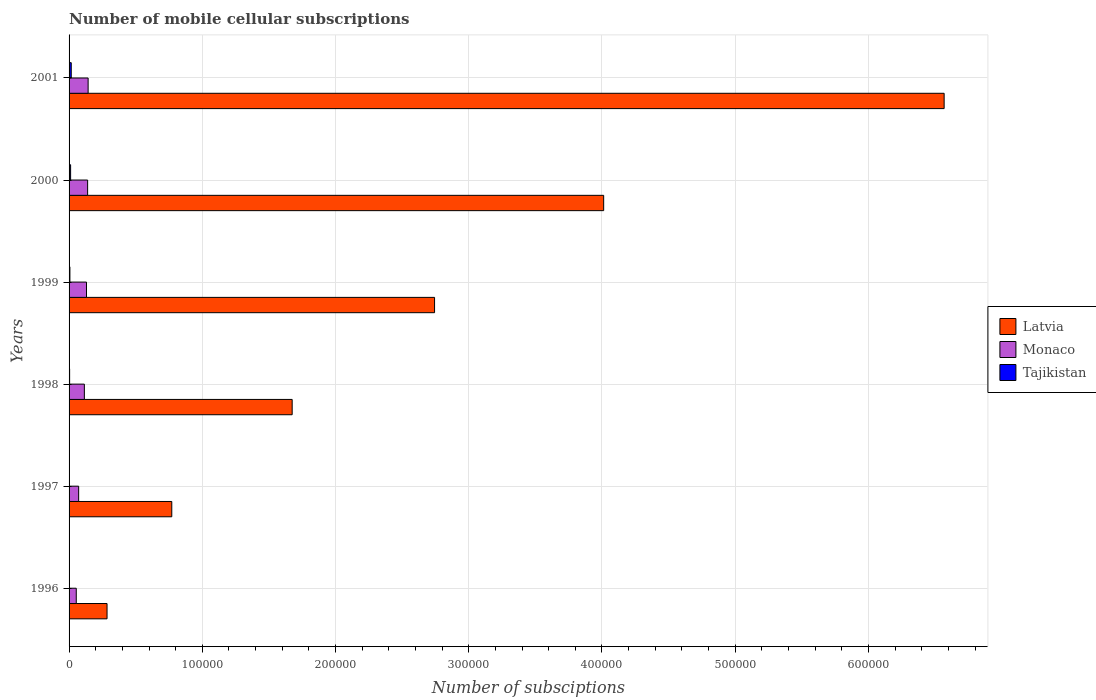Are the number of bars per tick equal to the number of legend labels?
Keep it short and to the point. Yes. Are the number of bars on each tick of the Y-axis equal?
Offer a very short reply. Yes. What is the label of the 3rd group of bars from the top?
Make the answer very short. 1999. In how many cases, is the number of bars for a given year not equal to the number of legend labels?
Keep it short and to the point. 0. What is the number of mobile cellular subscriptions in Monaco in 1999?
Ensure brevity in your answer.  1.31e+04. Across all years, what is the maximum number of mobile cellular subscriptions in Tajikistan?
Offer a very short reply. 1630. Across all years, what is the minimum number of mobile cellular subscriptions in Tajikistan?
Make the answer very short. 102. What is the total number of mobile cellular subscriptions in Monaco in the graph?
Give a very brief answer. 6.54e+04. What is the difference between the number of mobile cellular subscriptions in Latvia in 1998 and that in 1999?
Provide a succinct answer. -1.07e+05. What is the difference between the number of mobile cellular subscriptions in Tajikistan in 1996 and the number of mobile cellular subscriptions in Latvia in 1998?
Provide a short and direct response. -1.67e+05. What is the average number of mobile cellular subscriptions in Monaco per year?
Provide a short and direct response. 1.09e+04. In the year 1999, what is the difference between the number of mobile cellular subscriptions in Latvia and number of mobile cellular subscriptions in Tajikistan?
Give a very brief answer. 2.74e+05. What is the ratio of the number of mobile cellular subscriptions in Latvia in 1998 to that in 1999?
Offer a terse response. 0.61. Is the difference between the number of mobile cellular subscriptions in Latvia in 1998 and 1999 greater than the difference between the number of mobile cellular subscriptions in Tajikistan in 1998 and 1999?
Give a very brief answer. No. What is the difference between the highest and the second highest number of mobile cellular subscriptions in Monaco?
Ensure brevity in your answer.  375. What is the difference between the highest and the lowest number of mobile cellular subscriptions in Latvia?
Your answer should be very brief. 6.28e+05. In how many years, is the number of mobile cellular subscriptions in Tajikistan greater than the average number of mobile cellular subscriptions in Tajikistan taken over all years?
Ensure brevity in your answer.  2. What does the 2nd bar from the top in 1998 represents?
Make the answer very short. Monaco. What does the 1st bar from the bottom in 1998 represents?
Ensure brevity in your answer.  Latvia. Is it the case that in every year, the sum of the number of mobile cellular subscriptions in Monaco and number of mobile cellular subscriptions in Tajikistan is greater than the number of mobile cellular subscriptions in Latvia?
Ensure brevity in your answer.  No. Are all the bars in the graph horizontal?
Give a very brief answer. Yes. How many years are there in the graph?
Keep it short and to the point. 6. What is the difference between two consecutive major ticks on the X-axis?
Offer a very short reply. 1.00e+05. Are the values on the major ticks of X-axis written in scientific E-notation?
Offer a very short reply. No. Does the graph contain any zero values?
Provide a short and direct response. No. Does the graph contain grids?
Make the answer very short. Yes. Where does the legend appear in the graph?
Keep it short and to the point. Center right. How are the legend labels stacked?
Give a very brief answer. Vertical. What is the title of the graph?
Give a very brief answer. Number of mobile cellular subscriptions. Does "Guam" appear as one of the legend labels in the graph?
Your answer should be very brief. No. What is the label or title of the X-axis?
Make the answer very short. Number of subsciptions. What is the label or title of the Y-axis?
Offer a very short reply. Years. What is the Number of subsciptions of Latvia in 1996?
Your answer should be compact. 2.85e+04. What is the Number of subsciptions of Monaco in 1996?
Your response must be concise. 5400. What is the Number of subsciptions in Tajikistan in 1996?
Ensure brevity in your answer.  102. What is the Number of subsciptions of Latvia in 1997?
Your answer should be compact. 7.71e+04. What is the Number of subsciptions in Monaco in 1997?
Your answer should be very brief. 7200. What is the Number of subsciptions of Tajikistan in 1997?
Give a very brief answer. 320. What is the Number of subsciptions in Latvia in 1998?
Provide a short and direct response. 1.67e+05. What is the Number of subsciptions of Monaco in 1998?
Provide a succinct answer. 1.15e+04. What is the Number of subsciptions of Tajikistan in 1998?
Give a very brief answer. 420. What is the Number of subsciptions in Latvia in 1999?
Offer a very short reply. 2.74e+05. What is the Number of subsciptions in Monaco in 1999?
Provide a short and direct response. 1.31e+04. What is the Number of subsciptions of Tajikistan in 1999?
Keep it short and to the point. 625. What is the Number of subsciptions of Latvia in 2000?
Keep it short and to the point. 4.01e+05. What is the Number of subsciptions in Monaco in 2000?
Ensure brevity in your answer.  1.39e+04. What is the Number of subsciptions of Tajikistan in 2000?
Offer a terse response. 1160. What is the Number of subsciptions of Latvia in 2001?
Provide a succinct answer. 6.57e+05. What is the Number of subsciptions in Monaco in 2001?
Make the answer very short. 1.43e+04. What is the Number of subsciptions in Tajikistan in 2001?
Your answer should be very brief. 1630. Across all years, what is the maximum Number of subsciptions of Latvia?
Ensure brevity in your answer.  6.57e+05. Across all years, what is the maximum Number of subsciptions in Monaco?
Your answer should be very brief. 1.43e+04. Across all years, what is the maximum Number of subsciptions in Tajikistan?
Make the answer very short. 1630. Across all years, what is the minimum Number of subsciptions of Latvia?
Give a very brief answer. 2.85e+04. Across all years, what is the minimum Number of subsciptions of Monaco?
Ensure brevity in your answer.  5400. Across all years, what is the minimum Number of subsciptions in Tajikistan?
Give a very brief answer. 102. What is the total Number of subsciptions in Latvia in the graph?
Ensure brevity in your answer.  1.61e+06. What is the total Number of subsciptions of Monaco in the graph?
Your answer should be very brief. 6.54e+04. What is the total Number of subsciptions of Tajikistan in the graph?
Provide a short and direct response. 4257. What is the difference between the Number of subsciptions in Latvia in 1996 and that in 1997?
Provide a succinct answer. -4.86e+04. What is the difference between the Number of subsciptions in Monaco in 1996 and that in 1997?
Ensure brevity in your answer.  -1800. What is the difference between the Number of subsciptions in Tajikistan in 1996 and that in 1997?
Your answer should be very brief. -218. What is the difference between the Number of subsciptions in Latvia in 1996 and that in 1998?
Make the answer very short. -1.39e+05. What is the difference between the Number of subsciptions of Monaco in 1996 and that in 1998?
Your answer should be compact. -6074. What is the difference between the Number of subsciptions in Tajikistan in 1996 and that in 1998?
Provide a short and direct response. -318. What is the difference between the Number of subsciptions in Latvia in 1996 and that in 1999?
Ensure brevity in your answer.  -2.46e+05. What is the difference between the Number of subsciptions of Monaco in 1996 and that in 1999?
Your answer should be compact. -7680. What is the difference between the Number of subsciptions of Tajikistan in 1996 and that in 1999?
Offer a terse response. -523. What is the difference between the Number of subsciptions in Latvia in 1996 and that in 2000?
Offer a terse response. -3.73e+05. What is the difference between the Number of subsciptions of Monaco in 1996 and that in 2000?
Offer a terse response. -8527. What is the difference between the Number of subsciptions of Tajikistan in 1996 and that in 2000?
Make the answer very short. -1058. What is the difference between the Number of subsciptions of Latvia in 1996 and that in 2001?
Provide a short and direct response. -6.28e+05. What is the difference between the Number of subsciptions in Monaco in 1996 and that in 2001?
Make the answer very short. -8902. What is the difference between the Number of subsciptions in Tajikistan in 1996 and that in 2001?
Your answer should be very brief. -1528. What is the difference between the Number of subsciptions of Latvia in 1997 and that in 1998?
Your response must be concise. -9.04e+04. What is the difference between the Number of subsciptions of Monaco in 1997 and that in 1998?
Keep it short and to the point. -4274. What is the difference between the Number of subsciptions of Tajikistan in 1997 and that in 1998?
Offer a very short reply. -100. What is the difference between the Number of subsciptions in Latvia in 1997 and that in 1999?
Give a very brief answer. -1.97e+05. What is the difference between the Number of subsciptions in Monaco in 1997 and that in 1999?
Your answer should be compact. -5880. What is the difference between the Number of subsciptions of Tajikistan in 1997 and that in 1999?
Offer a terse response. -305. What is the difference between the Number of subsciptions in Latvia in 1997 and that in 2000?
Give a very brief answer. -3.24e+05. What is the difference between the Number of subsciptions in Monaco in 1997 and that in 2000?
Your response must be concise. -6727. What is the difference between the Number of subsciptions in Tajikistan in 1997 and that in 2000?
Your response must be concise. -840. What is the difference between the Number of subsciptions of Latvia in 1997 and that in 2001?
Give a very brief answer. -5.80e+05. What is the difference between the Number of subsciptions in Monaco in 1997 and that in 2001?
Give a very brief answer. -7102. What is the difference between the Number of subsciptions in Tajikistan in 1997 and that in 2001?
Offer a terse response. -1310. What is the difference between the Number of subsciptions of Latvia in 1998 and that in 1999?
Provide a short and direct response. -1.07e+05. What is the difference between the Number of subsciptions in Monaco in 1998 and that in 1999?
Your answer should be compact. -1606. What is the difference between the Number of subsciptions in Tajikistan in 1998 and that in 1999?
Provide a succinct answer. -205. What is the difference between the Number of subsciptions of Latvia in 1998 and that in 2000?
Keep it short and to the point. -2.34e+05. What is the difference between the Number of subsciptions in Monaco in 1998 and that in 2000?
Offer a very short reply. -2453. What is the difference between the Number of subsciptions of Tajikistan in 1998 and that in 2000?
Keep it short and to the point. -740. What is the difference between the Number of subsciptions of Latvia in 1998 and that in 2001?
Give a very brief answer. -4.89e+05. What is the difference between the Number of subsciptions in Monaco in 1998 and that in 2001?
Offer a terse response. -2828. What is the difference between the Number of subsciptions of Tajikistan in 1998 and that in 2001?
Make the answer very short. -1210. What is the difference between the Number of subsciptions of Latvia in 1999 and that in 2000?
Offer a very short reply. -1.27e+05. What is the difference between the Number of subsciptions of Monaco in 1999 and that in 2000?
Provide a short and direct response. -847. What is the difference between the Number of subsciptions of Tajikistan in 1999 and that in 2000?
Ensure brevity in your answer.  -535. What is the difference between the Number of subsciptions of Latvia in 1999 and that in 2001?
Give a very brief answer. -3.82e+05. What is the difference between the Number of subsciptions of Monaco in 1999 and that in 2001?
Your answer should be very brief. -1222. What is the difference between the Number of subsciptions in Tajikistan in 1999 and that in 2001?
Give a very brief answer. -1005. What is the difference between the Number of subsciptions of Latvia in 2000 and that in 2001?
Offer a terse response. -2.56e+05. What is the difference between the Number of subsciptions of Monaco in 2000 and that in 2001?
Offer a terse response. -375. What is the difference between the Number of subsciptions of Tajikistan in 2000 and that in 2001?
Keep it short and to the point. -470. What is the difference between the Number of subsciptions of Latvia in 1996 and the Number of subsciptions of Monaco in 1997?
Give a very brief answer. 2.13e+04. What is the difference between the Number of subsciptions of Latvia in 1996 and the Number of subsciptions of Tajikistan in 1997?
Keep it short and to the point. 2.82e+04. What is the difference between the Number of subsciptions of Monaco in 1996 and the Number of subsciptions of Tajikistan in 1997?
Offer a very short reply. 5080. What is the difference between the Number of subsciptions in Latvia in 1996 and the Number of subsciptions in Monaco in 1998?
Offer a very short reply. 1.70e+04. What is the difference between the Number of subsciptions of Latvia in 1996 and the Number of subsciptions of Tajikistan in 1998?
Provide a short and direct response. 2.81e+04. What is the difference between the Number of subsciptions of Monaco in 1996 and the Number of subsciptions of Tajikistan in 1998?
Ensure brevity in your answer.  4980. What is the difference between the Number of subsciptions in Latvia in 1996 and the Number of subsciptions in Monaco in 1999?
Make the answer very short. 1.54e+04. What is the difference between the Number of subsciptions in Latvia in 1996 and the Number of subsciptions in Tajikistan in 1999?
Your answer should be very brief. 2.79e+04. What is the difference between the Number of subsciptions in Monaco in 1996 and the Number of subsciptions in Tajikistan in 1999?
Ensure brevity in your answer.  4775. What is the difference between the Number of subsciptions in Latvia in 1996 and the Number of subsciptions in Monaco in 2000?
Your response must be concise. 1.46e+04. What is the difference between the Number of subsciptions of Latvia in 1996 and the Number of subsciptions of Tajikistan in 2000?
Give a very brief answer. 2.73e+04. What is the difference between the Number of subsciptions of Monaco in 1996 and the Number of subsciptions of Tajikistan in 2000?
Provide a succinct answer. 4240. What is the difference between the Number of subsciptions of Latvia in 1996 and the Number of subsciptions of Monaco in 2001?
Give a very brief answer. 1.42e+04. What is the difference between the Number of subsciptions of Latvia in 1996 and the Number of subsciptions of Tajikistan in 2001?
Provide a short and direct response. 2.69e+04. What is the difference between the Number of subsciptions in Monaco in 1996 and the Number of subsciptions in Tajikistan in 2001?
Keep it short and to the point. 3770. What is the difference between the Number of subsciptions in Latvia in 1997 and the Number of subsciptions in Monaco in 1998?
Your answer should be compact. 6.56e+04. What is the difference between the Number of subsciptions in Latvia in 1997 and the Number of subsciptions in Tajikistan in 1998?
Keep it short and to the point. 7.67e+04. What is the difference between the Number of subsciptions in Monaco in 1997 and the Number of subsciptions in Tajikistan in 1998?
Provide a short and direct response. 6780. What is the difference between the Number of subsciptions of Latvia in 1997 and the Number of subsciptions of Monaco in 1999?
Your answer should be very brief. 6.40e+04. What is the difference between the Number of subsciptions of Latvia in 1997 and the Number of subsciptions of Tajikistan in 1999?
Provide a succinct answer. 7.65e+04. What is the difference between the Number of subsciptions in Monaco in 1997 and the Number of subsciptions in Tajikistan in 1999?
Your response must be concise. 6575. What is the difference between the Number of subsciptions in Latvia in 1997 and the Number of subsciptions in Monaco in 2000?
Your answer should be very brief. 6.32e+04. What is the difference between the Number of subsciptions of Latvia in 1997 and the Number of subsciptions of Tajikistan in 2000?
Ensure brevity in your answer.  7.59e+04. What is the difference between the Number of subsciptions in Monaco in 1997 and the Number of subsciptions in Tajikistan in 2000?
Provide a short and direct response. 6040. What is the difference between the Number of subsciptions of Latvia in 1997 and the Number of subsciptions of Monaco in 2001?
Your answer should be very brief. 6.28e+04. What is the difference between the Number of subsciptions in Latvia in 1997 and the Number of subsciptions in Tajikistan in 2001?
Your answer should be very brief. 7.55e+04. What is the difference between the Number of subsciptions in Monaco in 1997 and the Number of subsciptions in Tajikistan in 2001?
Keep it short and to the point. 5570. What is the difference between the Number of subsciptions in Latvia in 1998 and the Number of subsciptions in Monaco in 1999?
Keep it short and to the point. 1.54e+05. What is the difference between the Number of subsciptions in Latvia in 1998 and the Number of subsciptions in Tajikistan in 1999?
Provide a succinct answer. 1.67e+05. What is the difference between the Number of subsciptions of Monaco in 1998 and the Number of subsciptions of Tajikistan in 1999?
Ensure brevity in your answer.  1.08e+04. What is the difference between the Number of subsciptions of Latvia in 1998 and the Number of subsciptions of Monaco in 2000?
Your response must be concise. 1.54e+05. What is the difference between the Number of subsciptions of Latvia in 1998 and the Number of subsciptions of Tajikistan in 2000?
Your response must be concise. 1.66e+05. What is the difference between the Number of subsciptions in Monaco in 1998 and the Number of subsciptions in Tajikistan in 2000?
Ensure brevity in your answer.  1.03e+04. What is the difference between the Number of subsciptions in Latvia in 1998 and the Number of subsciptions in Monaco in 2001?
Provide a succinct answer. 1.53e+05. What is the difference between the Number of subsciptions in Latvia in 1998 and the Number of subsciptions in Tajikistan in 2001?
Provide a short and direct response. 1.66e+05. What is the difference between the Number of subsciptions of Monaco in 1998 and the Number of subsciptions of Tajikistan in 2001?
Keep it short and to the point. 9844. What is the difference between the Number of subsciptions in Latvia in 1999 and the Number of subsciptions in Monaco in 2000?
Offer a terse response. 2.60e+05. What is the difference between the Number of subsciptions of Latvia in 1999 and the Number of subsciptions of Tajikistan in 2000?
Offer a very short reply. 2.73e+05. What is the difference between the Number of subsciptions in Monaco in 1999 and the Number of subsciptions in Tajikistan in 2000?
Offer a terse response. 1.19e+04. What is the difference between the Number of subsciptions in Latvia in 1999 and the Number of subsciptions in Monaco in 2001?
Keep it short and to the point. 2.60e+05. What is the difference between the Number of subsciptions of Latvia in 1999 and the Number of subsciptions of Tajikistan in 2001?
Your response must be concise. 2.73e+05. What is the difference between the Number of subsciptions of Monaco in 1999 and the Number of subsciptions of Tajikistan in 2001?
Your response must be concise. 1.14e+04. What is the difference between the Number of subsciptions in Latvia in 2000 and the Number of subsciptions in Monaco in 2001?
Provide a succinct answer. 3.87e+05. What is the difference between the Number of subsciptions of Latvia in 2000 and the Number of subsciptions of Tajikistan in 2001?
Provide a short and direct response. 4.00e+05. What is the difference between the Number of subsciptions in Monaco in 2000 and the Number of subsciptions in Tajikistan in 2001?
Give a very brief answer. 1.23e+04. What is the average Number of subsciptions of Latvia per year?
Your answer should be very brief. 2.68e+05. What is the average Number of subsciptions in Monaco per year?
Keep it short and to the point. 1.09e+04. What is the average Number of subsciptions of Tajikistan per year?
Your response must be concise. 709.5. In the year 1996, what is the difference between the Number of subsciptions in Latvia and Number of subsciptions in Monaco?
Your response must be concise. 2.31e+04. In the year 1996, what is the difference between the Number of subsciptions of Latvia and Number of subsciptions of Tajikistan?
Offer a terse response. 2.84e+04. In the year 1996, what is the difference between the Number of subsciptions in Monaco and Number of subsciptions in Tajikistan?
Provide a short and direct response. 5298. In the year 1997, what is the difference between the Number of subsciptions in Latvia and Number of subsciptions in Monaco?
Provide a succinct answer. 6.99e+04. In the year 1997, what is the difference between the Number of subsciptions in Latvia and Number of subsciptions in Tajikistan?
Keep it short and to the point. 7.68e+04. In the year 1997, what is the difference between the Number of subsciptions in Monaco and Number of subsciptions in Tajikistan?
Offer a very short reply. 6880. In the year 1998, what is the difference between the Number of subsciptions in Latvia and Number of subsciptions in Monaco?
Provide a succinct answer. 1.56e+05. In the year 1998, what is the difference between the Number of subsciptions in Latvia and Number of subsciptions in Tajikistan?
Your answer should be compact. 1.67e+05. In the year 1998, what is the difference between the Number of subsciptions of Monaco and Number of subsciptions of Tajikistan?
Your answer should be compact. 1.11e+04. In the year 1999, what is the difference between the Number of subsciptions of Latvia and Number of subsciptions of Monaco?
Offer a terse response. 2.61e+05. In the year 1999, what is the difference between the Number of subsciptions of Latvia and Number of subsciptions of Tajikistan?
Give a very brief answer. 2.74e+05. In the year 1999, what is the difference between the Number of subsciptions of Monaco and Number of subsciptions of Tajikistan?
Ensure brevity in your answer.  1.25e+04. In the year 2000, what is the difference between the Number of subsciptions of Latvia and Number of subsciptions of Monaco?
Your answer should be very brief. 3.87e+05. In the year 2000, what is the difference between the Number of subsciptions of Latvia and Number of subsciptions of Tajikistan?
Ensure brevity in your answer.  4.00e+05. In the year 2000, what is the difference between the Number of subsciptions in Monaco and Number of subsciptions in Tajikistan?
Make the answer very short. 1.28e+04. In the year 2001, what is the difference between the Number of subsciptions in Latvia and Number of subsciptions in Monaco?
Make the answer very short. 6.43e+05. In the year 2001, what is the difference between the Number of subsciptions in Latvia and Number of subsciptions in Tajikistan?
Your answer should be very brief. 6.55e+05. In the year 2001, what is the difference between the Number of subsciptions of Monaco and Number of subsciptions of Tajikistan?
Your response must be concise. 1.27e+04. What is the ratio of the Number of subsciptions of Latvia in 1996 to that in 1997?
Make the answer very short. 0.37. What is the ratio of the Number of subsciptions in Monaco in 1996 to that in 1997?
Offer a terse response. 0.75. What is the ratio of the Number of subsciptions in Tajikistan in 1996 to that in 1997?
Offer a terse response. 0.32. What is the ratio of the Number of subsciptions of Latvia in 1996 to that in 1998?
Your answer should be compact. 0.17. What is the ratio of the Number of subsciptions in Monaco in 1996 to that in 1998?
Provide a short and direct response. 0.47. What is the ratio of the Number of subsciptions in Tajikistan in 1996 to that in 1998?
Your answer should be compact. 0.24. What is the ratio of the Number of subsciptions in Latvia in 1996 to that in 1999?
Offer a terse response. 0.1. What is the ratio of the Number of subsciptions of Monaco in 1996 to that in 1999?
Your response must be concise. 0.41. What is the ratio of the Number of subsciptions in Tajikistan in 1996 to that in 1999?
Keep it short and to the point. 0.16. What is the ratio of the Number of subsciptions of Latvia in 1996 to that in 2000?
Offer a very short reply. 0.07. What is the ratio of the Number of subsciptions of Monaco in 1996 to that in 2000?
Ensure brevity in your answer.  0.39. What is the ratio of the Number of subsciptions of Tajikistan in 1996 to that in 2000?
Keep it short and to the point. 0.09. What is the ratio of the Number of subsciptions of Latvia in 1996 to that in 2001?
Offer a terse response. 0.04. What is the ratio of the Number of subsciptions of Monaco in 1996 to that in 2001?
Make the answer very short. 0.38. What is the ratio of the Number of subsciptions of Tajikistan in 1996 to that in 2001?
Give a very brief answer. 0.06. What is the ratio of the Number of subsciptions of Latvia in 1997 to that in 1998?
Your response must be concise. 0.46. What is the ratio of the Number of subsciptions in Monaco in 1997 to that in 1998?
Your answer should be compact. 0.63. What is the ratio of the Number of subsciptions in Tajikistan in 1997 to that in 1998?
Give a very brief answer. 0.76. What is the ratio of the Number of subsciptions of Latvia in 1997 to that in 1999?
Your answer should be compact. 0.28. What is the ratio of the Number of subsciptions of Monaco in 1997 to that in 1999?
Offer a very short reply. 0.55. What is the ratio of the Number of subsciptions in Tajikistan in 1997 to that in 1999?
Your answer should be compact. 0.51. What is the ratio of the Number of subsciptions of Latvia in 1997 to that in 2000?
Provide a succinct answer. 0.19. What is the ratio of the Number of subsciptions in Monaco in 1997 to that in 2000?
Ensure brevity in your answer.  0.52. What is the ratio of the Number of subsciptions of Tajikistan in 1997 to that in 2000?
Offer a terse response. 0.28. What is the ratio of the Number of subsciptions of Latvia in 1997 to that in 2001?
Provide a succinct answer. 0.12. What is the ratio of the Number of subsciptions of Monaco in 1997 to that in 2001?
Give a very brief answer. 0.5. What is the ratio of the Number of subsciptions of Tajikistan in 1997 to that in 2001?
Ensure brevity in your answer.  0.2. What is the ratio of the Number of subsciptions of Latvia in 1998 to that in 1999?
Your answer should be compact. 0.61. What is the ratio of the Number of subsciptions in Monaco in 1998 to that in 1999?
Ensure brevity in your answer.  0.88. What is the ratio of the Number of subsciptions in Tajikistan in 1998 to that in 1999?
Offer a terse response. 0.67. What is the ratio of the Number of subsciptions of Latvia in 1998 to that in 2000?
Your answer should be compact. 0.42. What is the ratio of the Number of subsciptions in Monaco in 1998 to that in 2000?
Ensure brevity in your answer.  0.82. What is the ratio of the Number of subsciptions in Tajikistan in 1998 to that in 2000?
Provide a succinct answer. 0.36. What is the ratio of the Number of subsciptions of Latvia in 1998 to that in 2001?
Ensure brevity in your answer.  0.25. What is the ratio of the Number of subsciptions in Monaco in 1998 to that in 2001?
Your answer should be very brief. 0.8. What is the ratio of the Number of subsciptions of Tajikistan in 1998 to that in 2001?
Offer a terse response. 0.26. What is the ratio of the Number of subsciptions in Latvia in 1999 to that in 2000?
Ensure brevity in your answer.  0.68. What is the ratio of the Number of subsciptions in Monaco in 1999 to that in 2000?
Make the answer very short. 0.94. What is the ratio of the Number of subsciptions in Tajikistan in 1999 to that in 2000?
Your answer should be compact. 0.54. What is the ratio of the Number of subsciptions in Latvia in 1999 to that in 2001?
Your response must be concise. 0.42. What is the ratio of the Number of subsciptions of Monaco in 1999 to that in 2001?
Your answer should be compact. 0.91. What is the ratio of the Number of subsciptions in Tajikistan in 1999 to that in 2001?
Your response must be concise. 0.38. What is the ratio of the Number of subsciptions of Latvia in 2000 to that in 2001?
Provide a short and direct response. 0.61. What is the ratio of the Number of subsciptions of Monaco in 2000 to that in 2001?
Your answer should be compact. 0.97. What is the ratio of the Number of subsciptions of Tajikistan in 2000 to that in 2001?
Provide a short and direct response. 0.71. What is the difference between the highest and the second highest Number of subsciptions in Latvia?
Provide a short and direct response. 2.56e+05. What is the difference between the highest and the second highest Number of subsciptions of Monaco?
Provide a succinct answer. 375. What is the difference between the highest and the second highest Number of subsciptions in Tajikistan?
Make the answer very short. 470. What is the difference between the highest and the lowest Number of subsciptions in Latvia?
Your answer should be compact. 6.28e+05. What is the difference between the highest and the lowest Number of subsciptions of Monaco?
Your response must be concise. 8902. What is the difference between the highest and the lowest Number of subsciptions of Tajikistan?
Provide a succinct answer. 1528. 